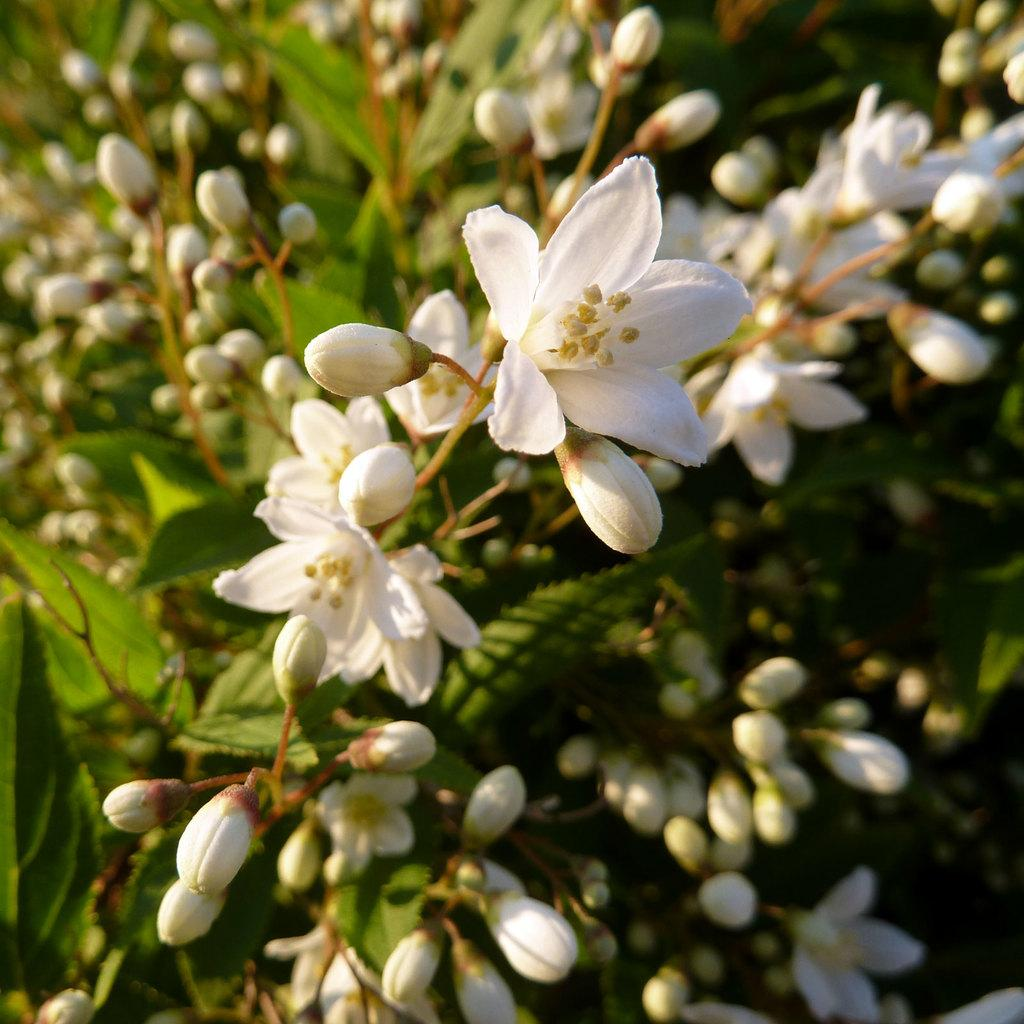What type of plants are visible in the image? There are white color flower plants in the image. Can you describe the background of the image? The background of the image is blurred. What type of popcorn is being served in the image? There is no popcorn present in the image; it features white color flower plants. How does the stomach of the person in the image look? There is no person present in the image, so it is not possible to comment on the appearance of their stomach. 